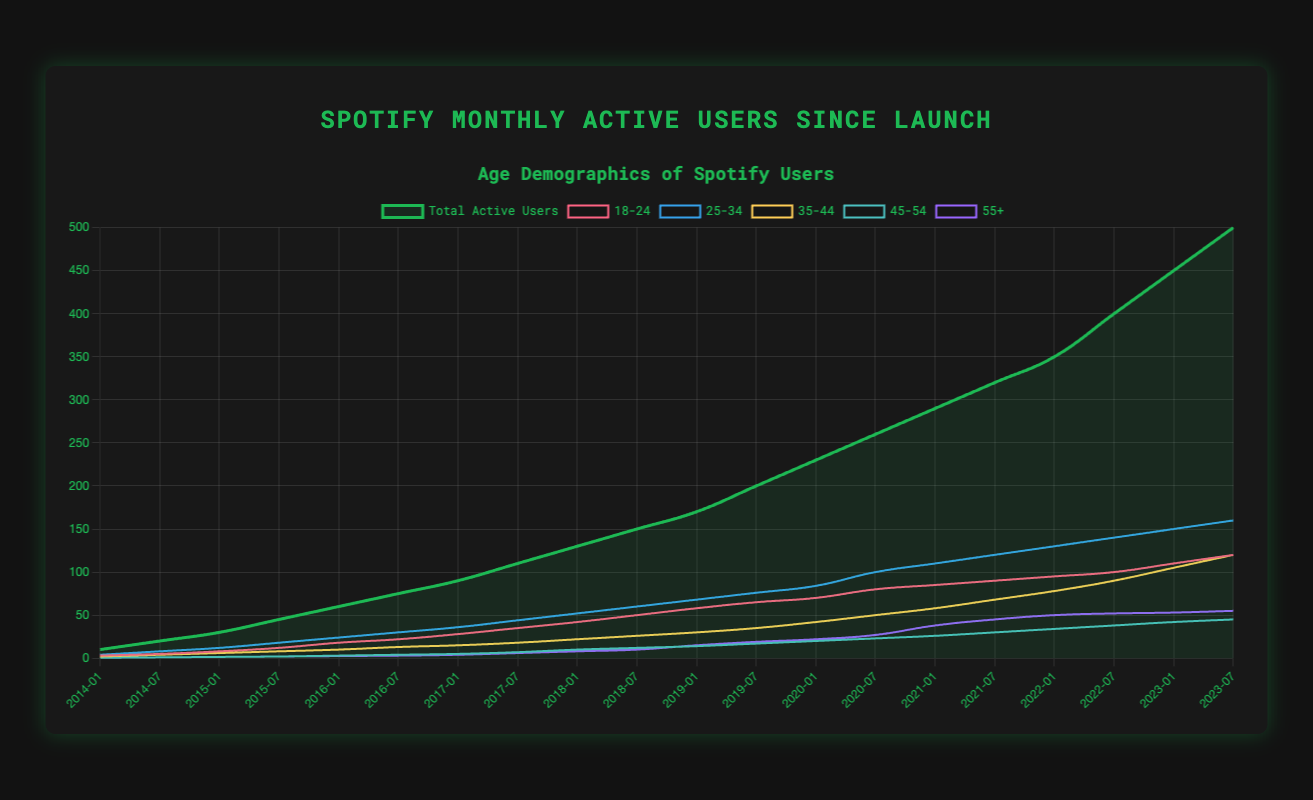Which age group saw the largest growth from 2014 to 2023? By inspecting the increase in active users for each age group, we see that the '25-34' age group grew from 4 users in 2014-01 to 160 users in 2023-07, representing an increase of 156. Comparatively, other groups grew less.
Answer: 25-34 In which year did Spotify's total active users first exceed 100 million? Looking at the total active users line, Spotify's total active users reached 110 million between 2017-07 and 2018-01. It first exceeded 100 million most likely around the midpoint of this range.
Answer: 2018 Which age group had the least increase in active users from 2014-01 to 2023-07? The smallest increase was observed in the '45-54' group, which grew from 0.5 users in 2014-01 to 45 users in 2023-07, a difference of 44.5 users, being the lowest among all age groups.
Answer: 45-54 What is the average number of active users in the 18-24 age group in the years 2016 and 2017? Calculate the values in the 18-24 age group for each date in 2016 and 2017: [18, 22, 28, 35]. Sum these (18 + 22 + 28 + 35 = 103) and divide by the number of values (4).
Answer: 25.75 Which age group had the highest number of active users in 2023-07? In 2023-07, the '25-34' age group had the highest number of active users, reaching 160, which is greater than any other age group for this time point.
Answer: 25-34 Comparing the first half of 2020, which age group's active users grew the fastest? Between 2020-01 and 2020-07, the '25-34' age group grew from 84 to 100, an increase of 16, the fastest among all groups in this duration.
Answer: 25-34 What percentage of total users in 2023-07 does the 18-24 age group represent? The 18-24 age group had 120 users out of a total of 500 in 2023-07. To find the percentage: (120/500) * 100 = 24%.
Answer: 24% Between 2019-01 and 2020-01, did the 55+ age group's growth exceed 30%? The 55+ age group's numbers were 15 in 2019-01 and 22 in 2020-01. The percentage increase is ((22-15)/15) * 100 = 46.67%.
Answer: Yes Which year did the '35-44' age group see the highest increase in active users? By analyzing the '35-44' data, the highest increase occurred between 2020-07 (58 users) and 2021-07 (68 users) with an increase of 10 users.
Answer: 2021 How many users were added in the '18-24' age group between 2014 and 2016? The '18-24' age group had 3 users in 2014-01 and 22 users in 2016-07. Subtracting these numbers gives 22 - 3 = 19 users.
Answer: 19 